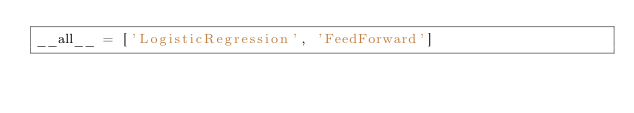<code> <loc_0><loc_0><loc_500><loc_500><_Python_>__all__ = ['LogisticRegression', 'FeedForward']
</code> 